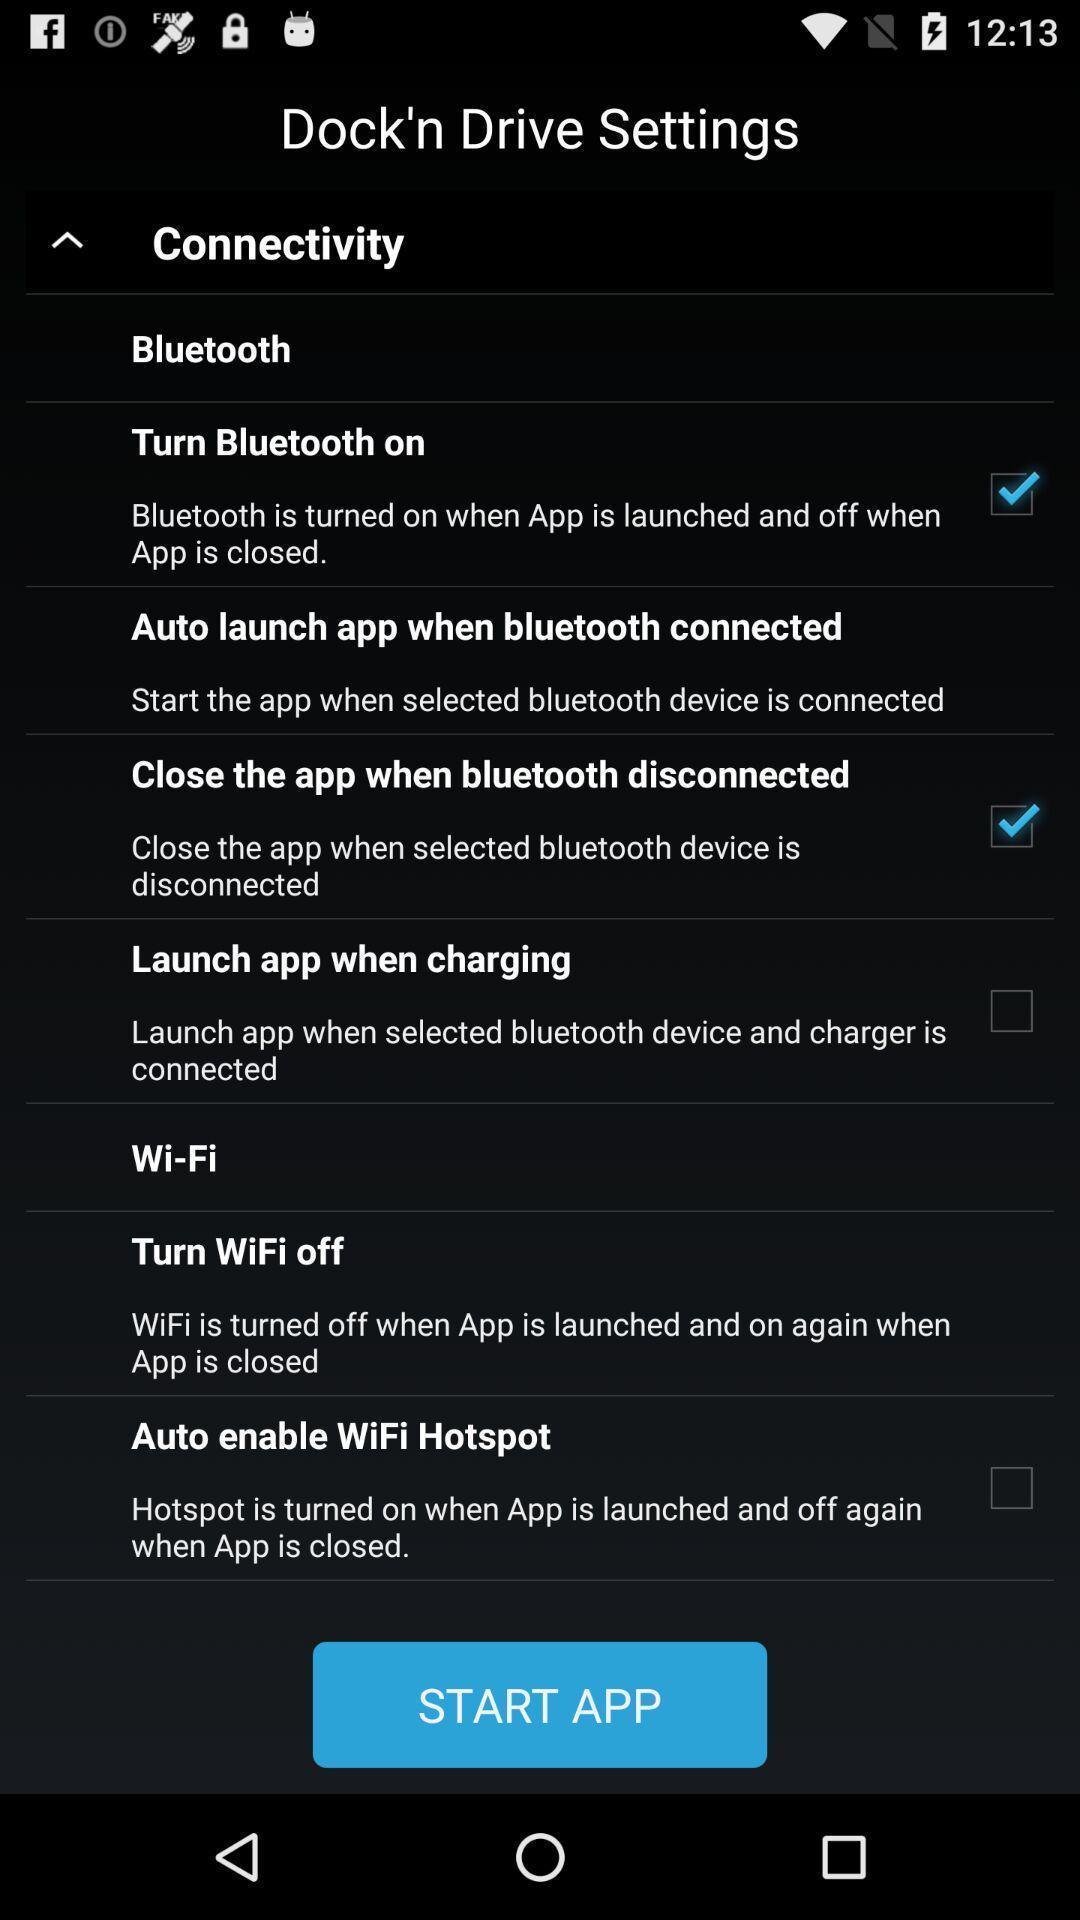Describe this image in words. Welcome page with various settings. 